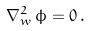Convert formula to latex. <formula><loc_0><loc_0><loc_500><loc_500>\nabla _ { w } ^ { 2 } \, \phi = 0 \, .</formula> 